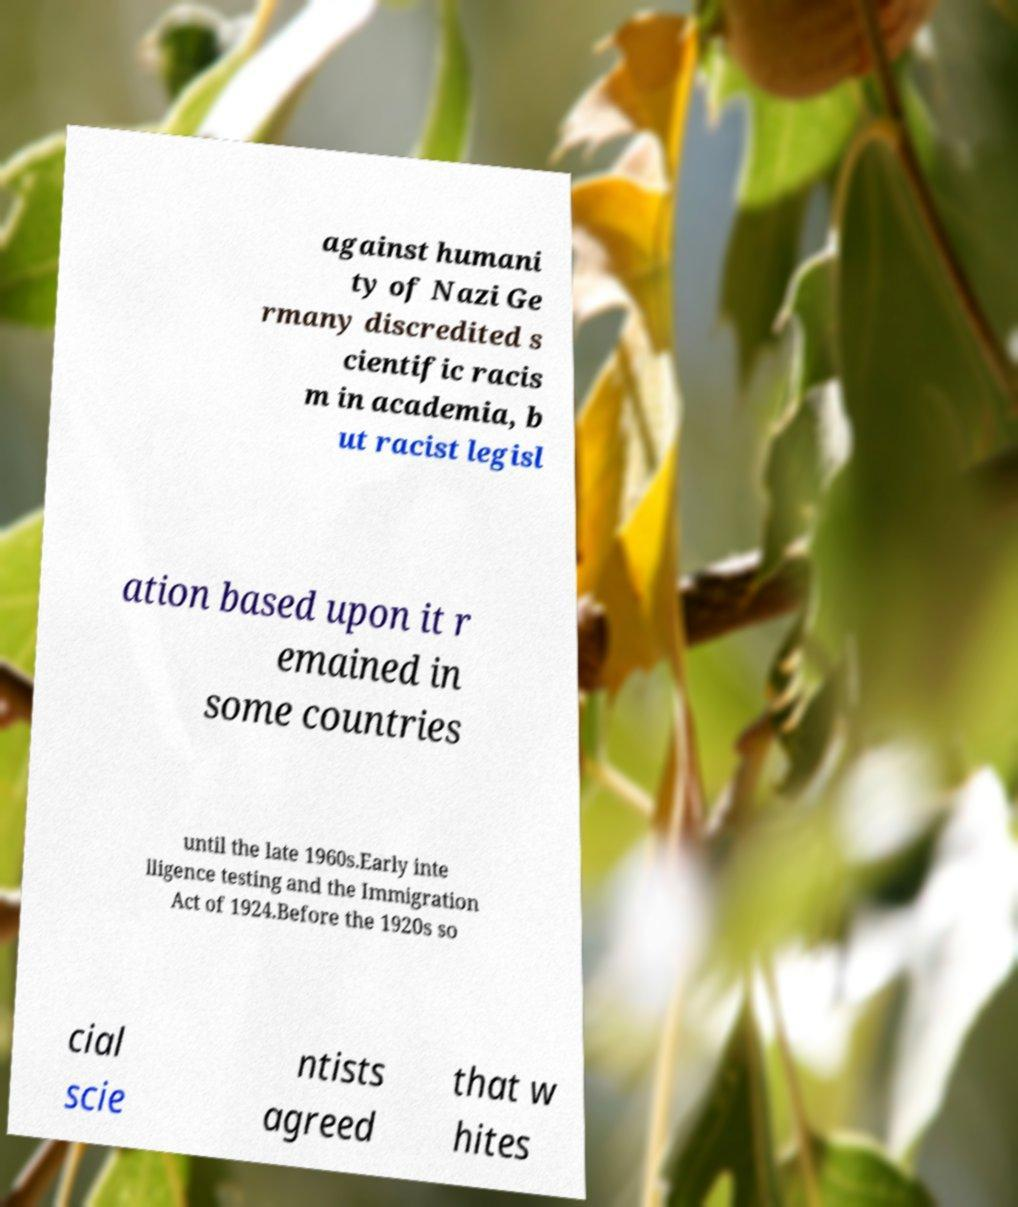For documentation purposes, I need the text within this image transcribed. Could you provide that? against humani ty of Nazi Ge rmany discredited s cientific racis m in academia, b ut racist legisl ation based upon it r emained in some countries until the late 1960s.Early inte lligence testing and the Immigration Act of 1924.Before the 1920s so cial scie ntists agreed that w hites 